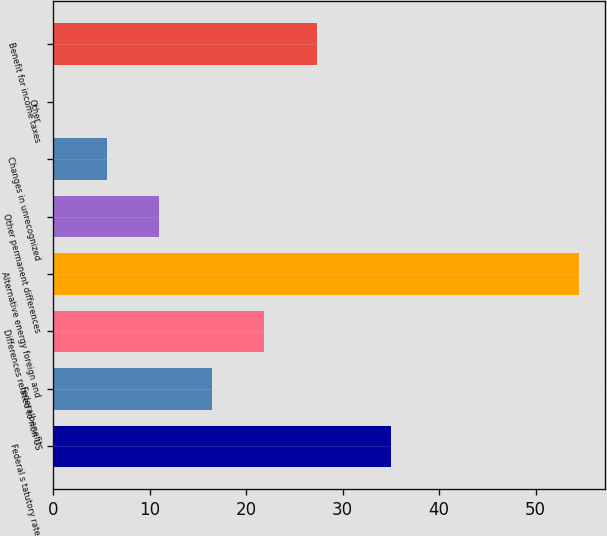Convert chart to OTSL. <chart><loc_0><loc_0><loc_500><loc_500><bar_chart><fcel>Federal s tatutory rate<fcel>Federalbenefit<fcel>Differences related to non US<fcel>Alternative energy foreign and<fcel>Other permanent differences<fcel>Changes in unrecognized<fcel>Other<fcel>Benefit for income taxes<nl><fcel>35<fcel>16.42<fcel>21.86<fcel>54.5<fcel>10.98<fcel>5.54<fcel>0.1<fcel>27.3<nl></chart> 